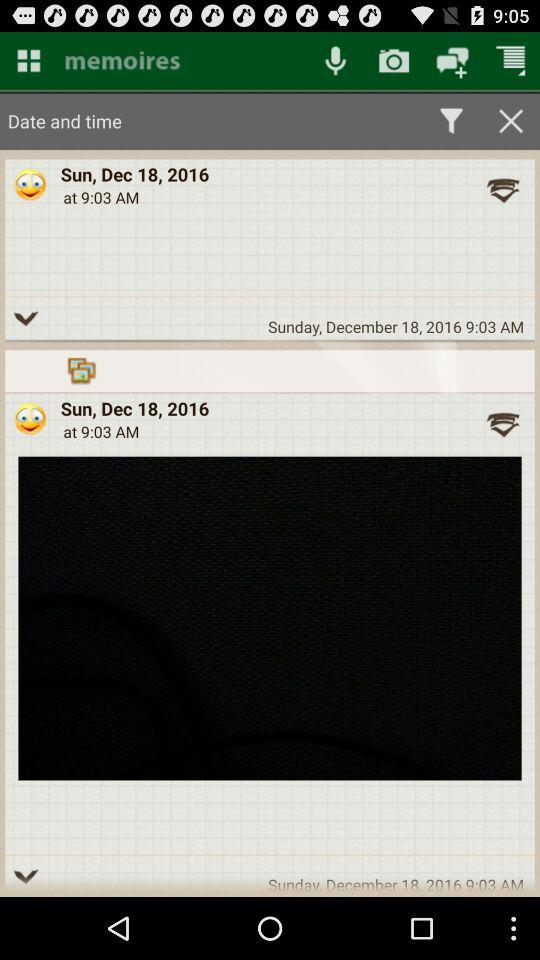What is the given date and time? The given date is Sunday, December 18, 2016 and the time is 9:03 AM. 